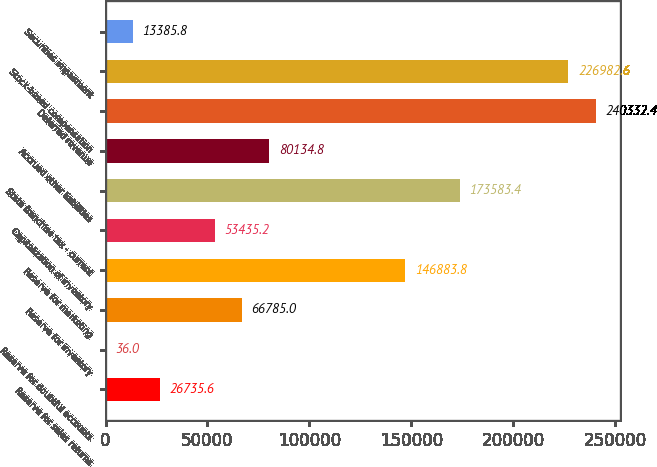Convert chart to OTSL. <chart><loc_0><loc_0><loc_500><loc_500><bar_chart><fcel>Reserve for sales returns<fcel>Reserve for doubtful accounts<fcel>Reserve for inventory<fcel>Reserve for marketing<fcel>Capitalization of inventory<fcel>State franchise tax - current<fcel>Accrued other liabilities<fcel>Deferred revenue<fcel>Stock-based compensation<fcel>Securities impairment<nl><fcel>26735.6<fcel>36<fcel>66785<fcel>146884<fcel>53435.2<fcel>173583<fcel>80134.8<fcel>240332<fcel>226983<fcel>13385.8<nl></chart> 